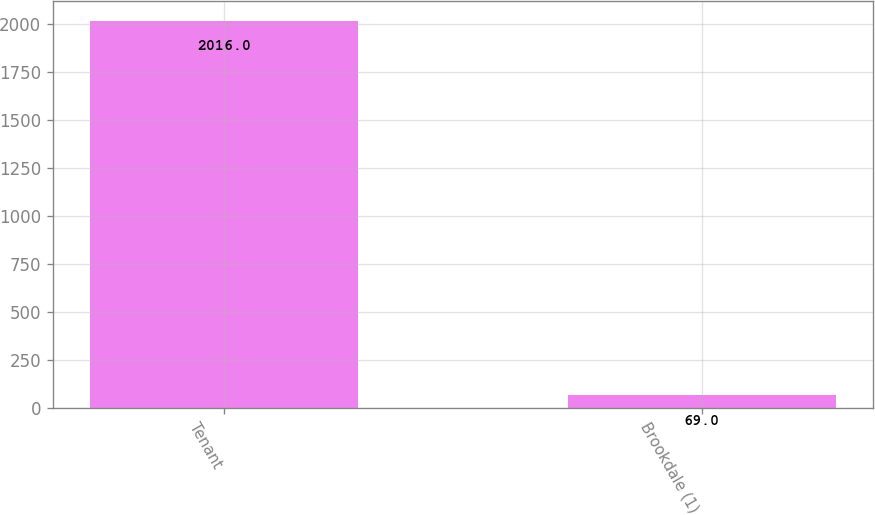<chart> <loc_0><loc_0><loc_500><loc_500><bar_chart><fcel>Tenant<fcel>Brookdale (1)<nl><fcel>2016<fcel>69<nl></chart> 